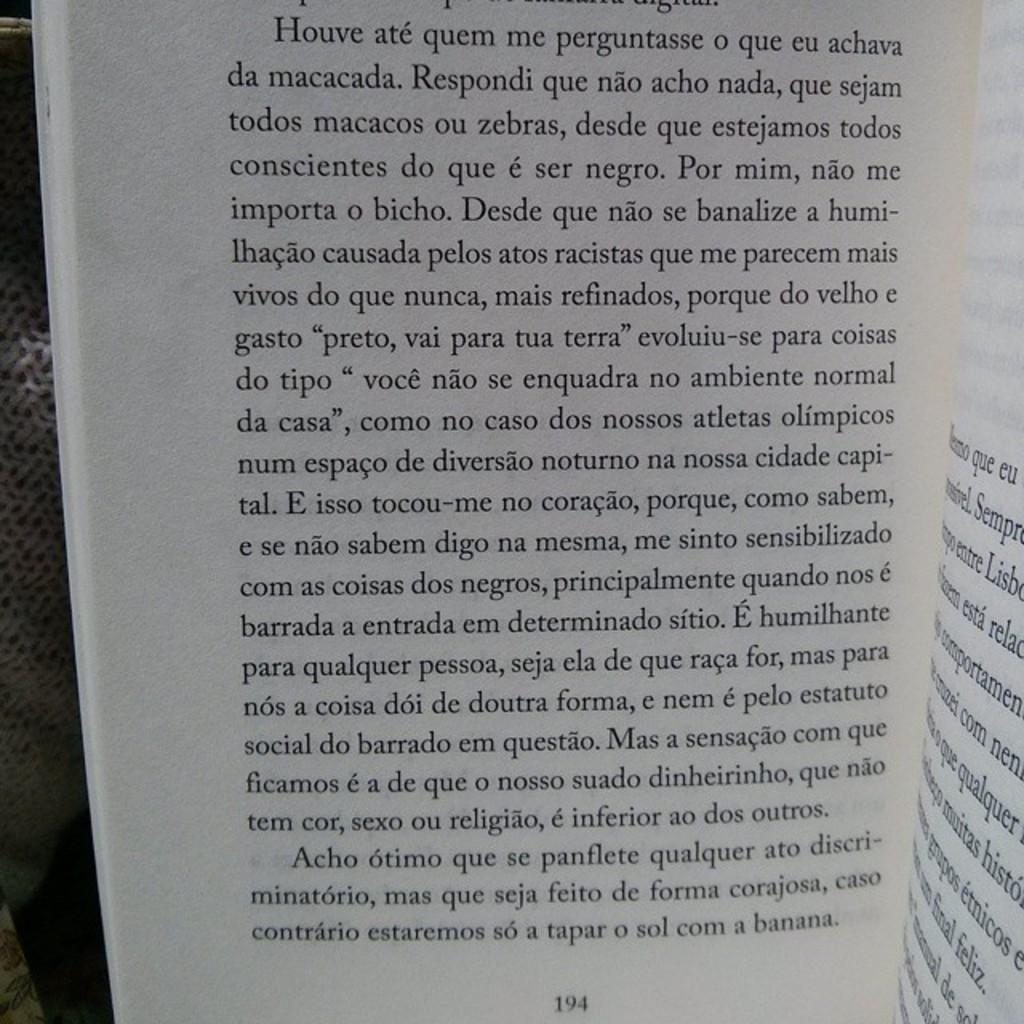<image>
Describe the image concisely. Page 194 of a book written in French ends with the word banana. 